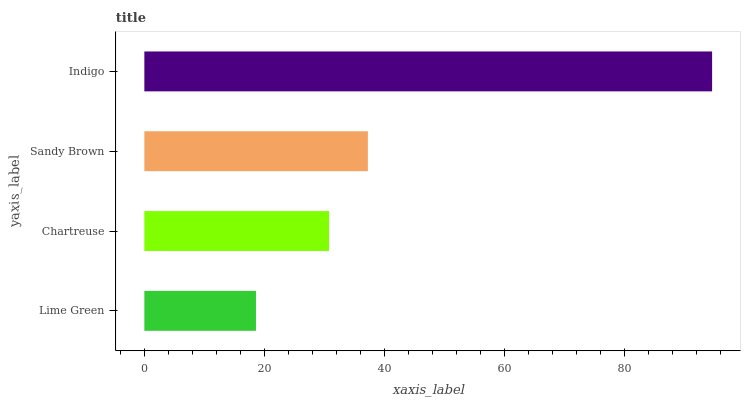Is Lime Green the minimum?
Answer yes or no. Yes. Is Indigo the maximum?
Answer yes or no. Yes. Is Chartreuse the minimum?
Answer yes or no. No. Is Chartreuse the maximum?
Answer yes or no. No. Is Chartreuse greater than Lime Green?
Answer yes or no. Yes. Is Lime Green less than Chartreuse?
Answer yes or no. Yes. Is Lime Green greater than Chartreuse?
Answer yes or no. No. Is Chartreuse less than Lime Green?
Answer yes or no. No. Is Sandy Brown the high median?
Answer yes or no. Yes. Is Chartreuse the low median?
Answer yes or no. Yes. Is Indigo the high median?
Answer yes or no. No. Is Indigo the low median?
Answer yes or no. No. 